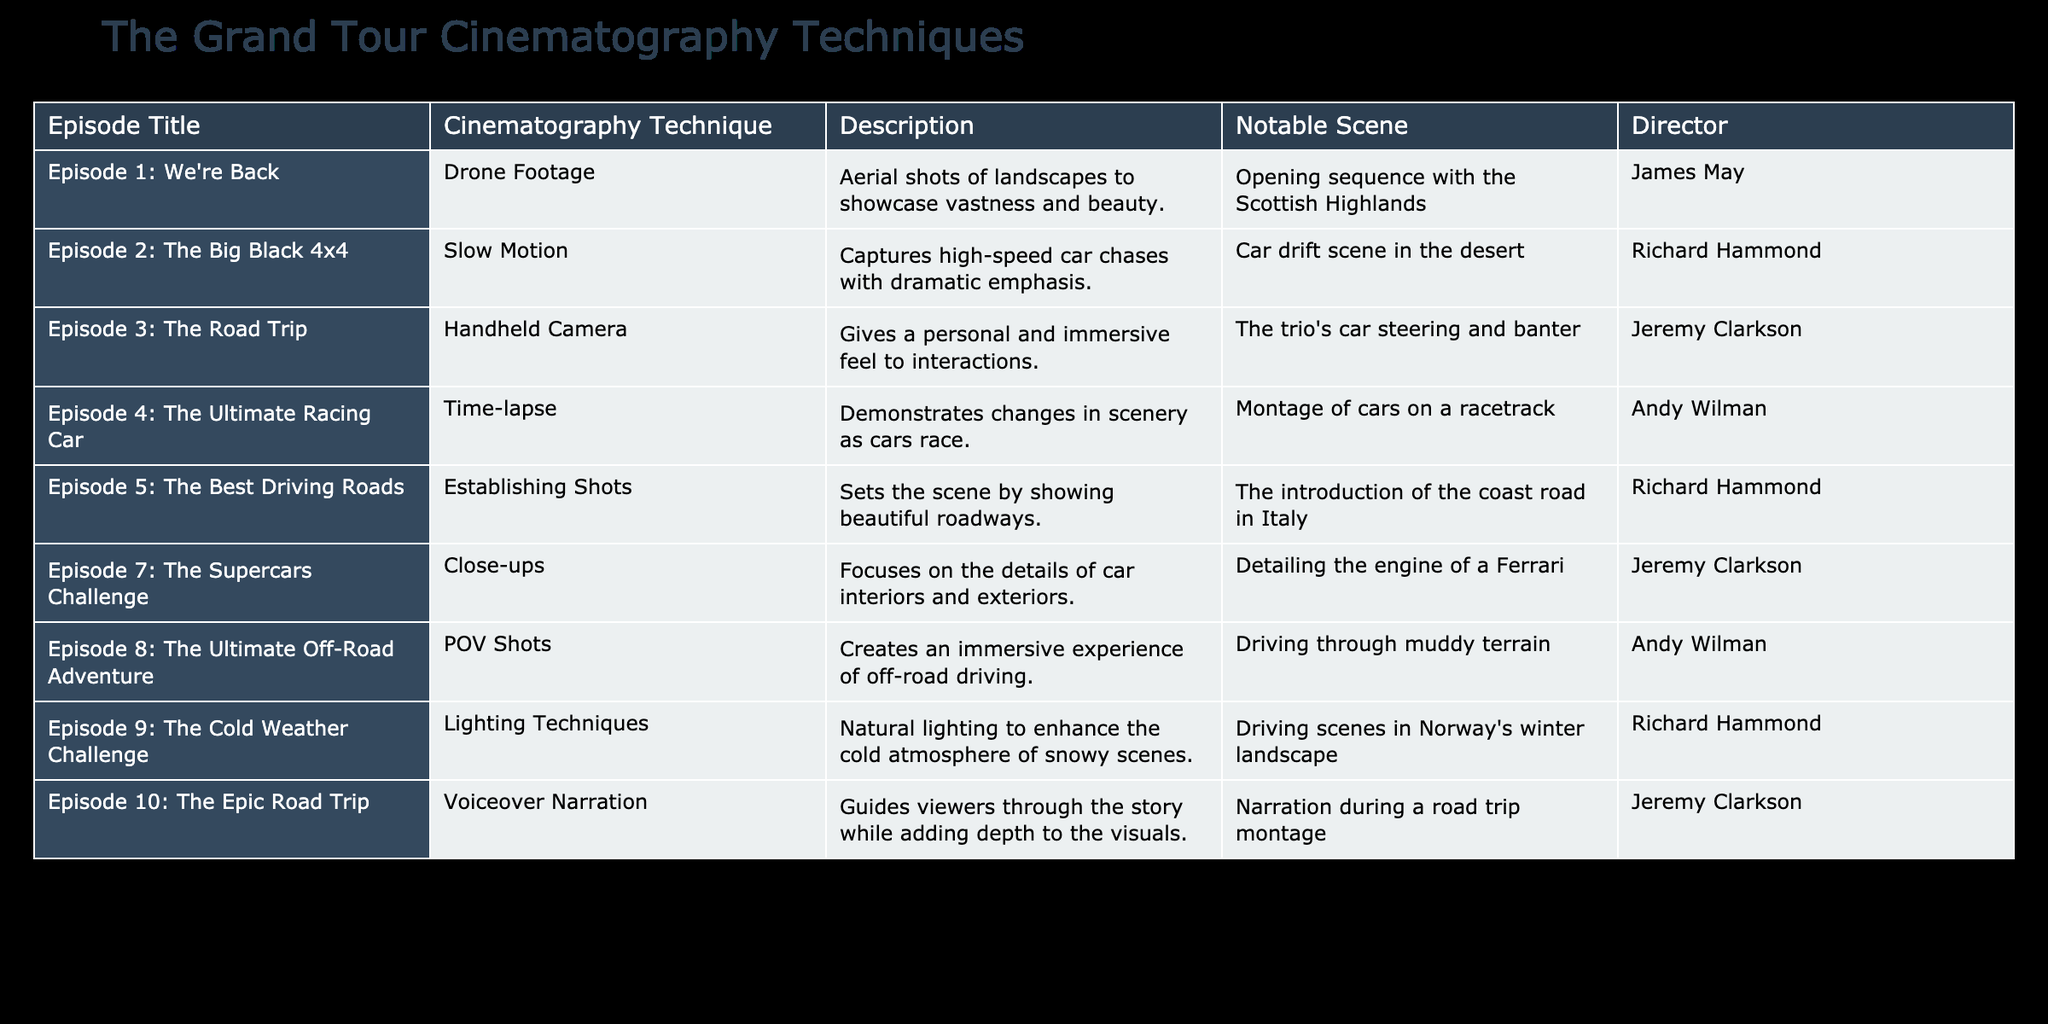What cinematography technique is used in "Episode 1: We're Back"? The table shows that "Episode 1: We're Back" employs Drone Footage as the cinematography technique.
Answer: Drone Footage Which episode features Slow Motion as a cinematography technique? The table indicates that "Episode 2: The Big Black 4x4" uses Slow Motion for its cinematography technique.
Answer: Episode 2: The Big Black 4x4 How many episodes use Close-ups as a cinematography technique? The table lists only one episode using Close-ups, which is "Episode 7: The Supercars Challenge." Therefore, the answer is one.
Answer: 1 What is the notable scene that uses Handheld Camera technique? According to the table, the notable scene for Handheld Camera technique is the trio's car steering and banter in "Episode 3: The Road Trip."
Answer: The trio's car steering and banter Which cinematography technique is associated with "Driving through muddy terrain"? The table states that the technique associated with the notable scene "Driving through muddy terrain" is POV Shots from "Episode 8: The Ultimate Off-Road Adventure."
Answer: POV Shots Do any episodes use Voiceover Narration for storytelling? Yes, the table indicates that "Episode 10: The Epic Road Trip" uses Voiceover Narration as a cinematography technique.
Answer: Yes What is the average number of episodes directed by Jeremy Clarkson? From the table, Jeremy Clarkson directed "Episode 3: The Road Trip," "Episode 7: The Supercars Challenge," and "Episode 10: The Epic Road Trip," totaling 3 episodes. The average is therefore 3/3 = 1, as we consider each episode as 1 unit.
Answer: 1 Which episode has the notable scene of "Driving scenes in Norway's winter landscape"? The notable scene described as "Driving scenes in Norway's winter landscape" is from "Episode 9: The Cold Weather Challenge."
Answer: Episode 9: The Cold Weather Challenge What are the two cinematography techniques that use natural settings, and which episodes utilize them? The table shows that Drone Footage ("Episode 1: We're Back") and Lighting Techniques ("Episode 9: The Cold Weather Challenge") both use natural settings to enhance the viewing experience.
Answer: Drone Footage and Lighting Techniques 